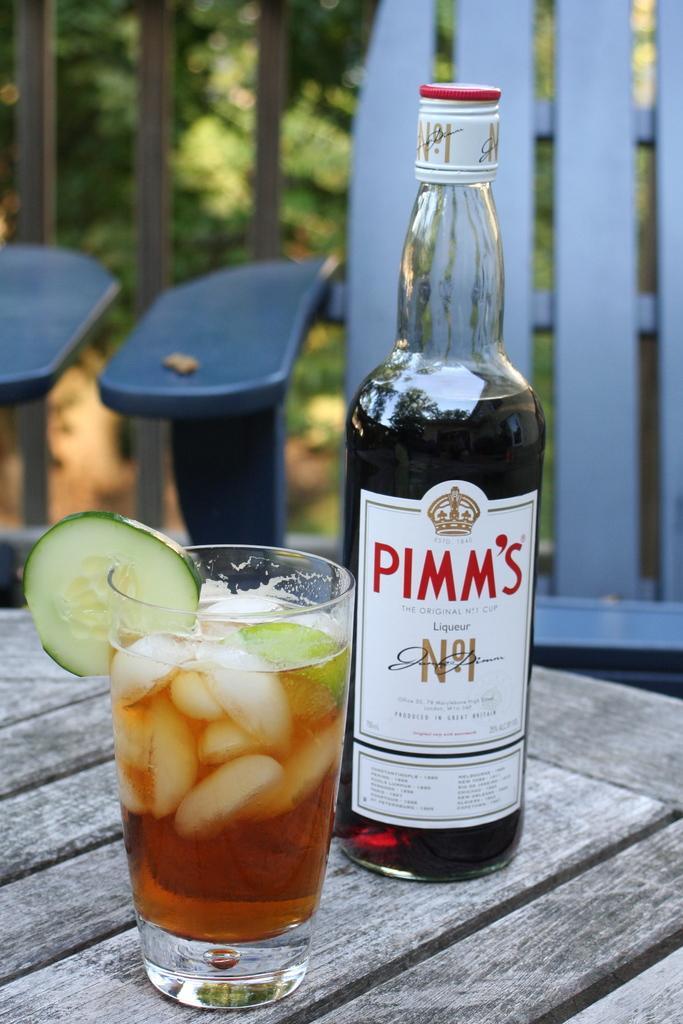Describe this image in one or two sentences. In this image I can see there is a glass and bottles kept on the table ,back side I can see a fence and there are some trees visible ,back side of the fence. on the glass there is a drink. 